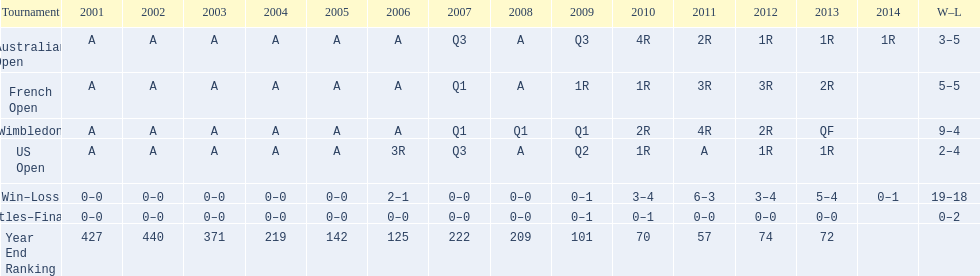What is the variation in wins between wimbledon and the us open for this competitor? 7. 